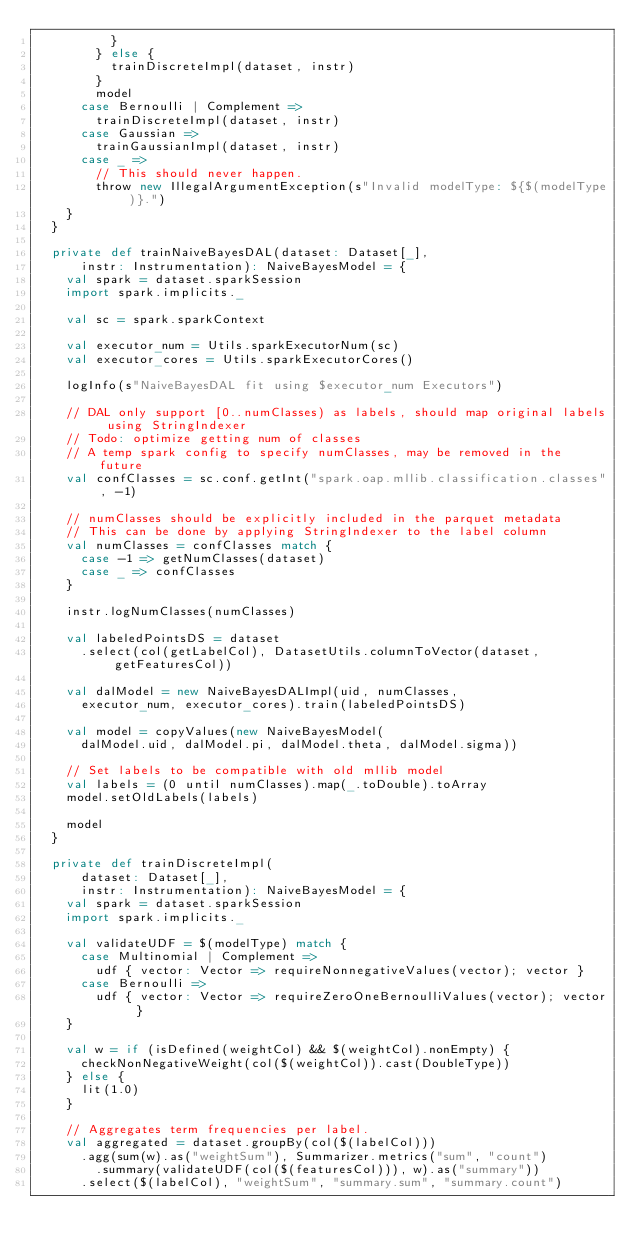Convert code to text. <code><loc_0><loc_0><loc_500><loc_500><_Scala_>          }
        } else {
          trainDiscreteImpl(dataset, instr)
        }
        model
      case Bernoulli | Complement =>
        trainDiscreteImpl(dataset, instr)
      case Gaussian =>
        trainGaussianImpl(dataset, instr)
      case _ =>
        // This should never happen.
        throw new IllegalArgumentException(s"Invalid modelType: ${$(modelType)}.")
    }
  }

  private def trainNaiveBayesDAL(dataset: Dataset[_],
      instr: Instrumentation): NaiveBayesModel = {
    val spark = dataset.sparkSession
    import spark.implicits._

    val sc = spark.sparkContext

    val executor_num = Utils.sparkExecutorNum(sc)
    val executor_cores = Utils.sparkExecutorCores()

    logInfo(s"NaiveBayesDAL fit using $executor_num Executors")

    // DAL only support [0..numClasses) as labels, should map original labels using StringIndexer
    // Todo: optimize getting num of classes
    // A temp spark config to specify numClasses, may be removed in the future
    val confClasses = sc.conf.getInt("spark.oap.mllib.classification.classes", -1)

    // numClasses should be explicitly included in the parquet metadata
    // This can be done by applying StringIndexer to the label column
    val numClasses = confClasses match {
      case -1 => getNumClasses(dataset)
      case _ => confClasses
    }

    instr.logNumClasses(numClasses)

    val labeledPointsDS = dataset
      .select(col(getLabelCol), DatasetUtils.columnToVector(dataset, getFeaturesCol))

    val dalModel = new NaiveBayesDALImpl(uid, numClasses,
      executor_num, executor_cores).train(labeledPointsDS)

    val model = copyValues(new NaiveBayesModel(
      dalModel.uid, dalModel.pi, dalModel.theta, dalModel.sigma))

    // Set labels to be compatible with old mllib model
    val labels = (0 until numClasses).map(_.toDouble).toArray
    model.setOldLabels(labels)

    model
  }

  private def trainDiscreteImpl(
      dataset: Dataset[_],
      instr: Instrumentation): NaiveBayesModel = {
    val spark = dataset.sparkSession
    import spark.implicits._

    val validateUDF = $(modelType) match {
      case Multinomial | Complement =>
        udf { vector: Vector => requireNonnegativeValues(vector); vector }
      case Bernoulli =>
        udf { vector: Vector => requireZeroOneBernoulliValues(vector); vector }
    }

    val w = if (isDefined(weightCol) && $(weightCol).nonEmpty) {
      checkNonNegativeWeight(col($(weightCol)).cast(DoubleType))
    } else {
      lit(1.0)
    }

    // Aggregates term frequencies per label.
    val aggregated = dataset.groupBy(col($(labelCol)))
      .agg(sum(w).as("weightSum"), Summarizer.metrics("sum", "count")
        .summary(validateUDF(col($(featuresCol))), w).as("summary"))
      .select($(labelCol), "weightSum", "summary.sum", "summary.count")</code> 